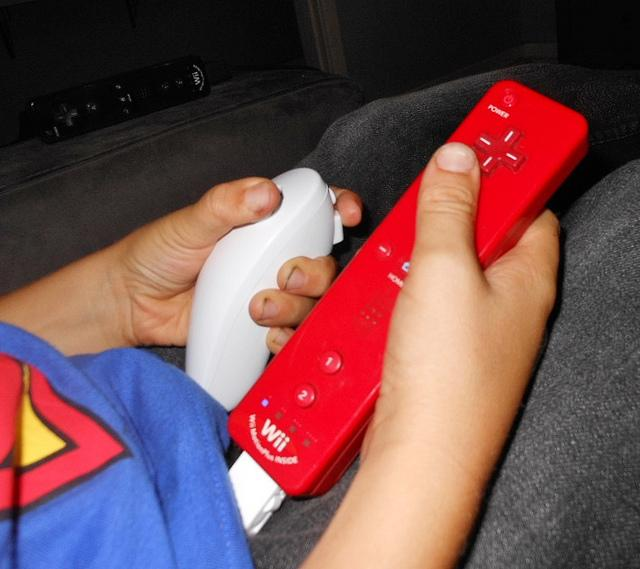What was the first item manufactured by the company that makes the remote?

Choices:
A) pinball machine
B) playing cards
C) slot machine
D) comic books playing cards 